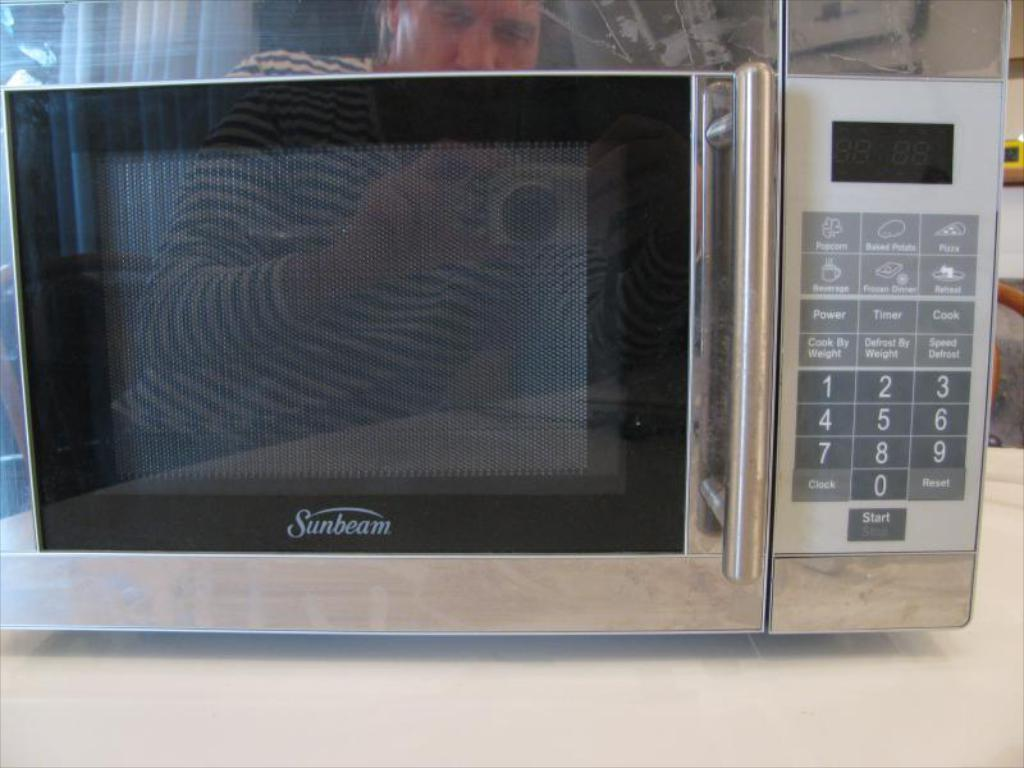<image>
Present a compact description of the photo's key features. A man's reflection can be seen in the face of a Sunbeam microwave that is sitting on a counter. 